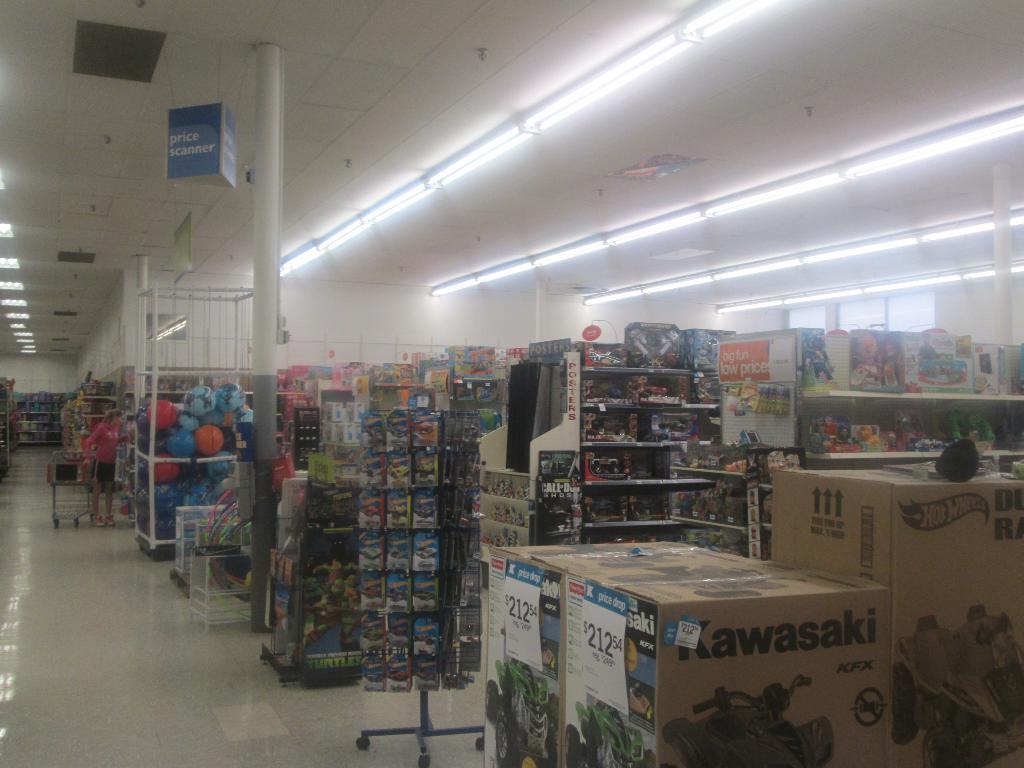What is the price of the four wheeler?
Offer a very short reply. 212.54. 